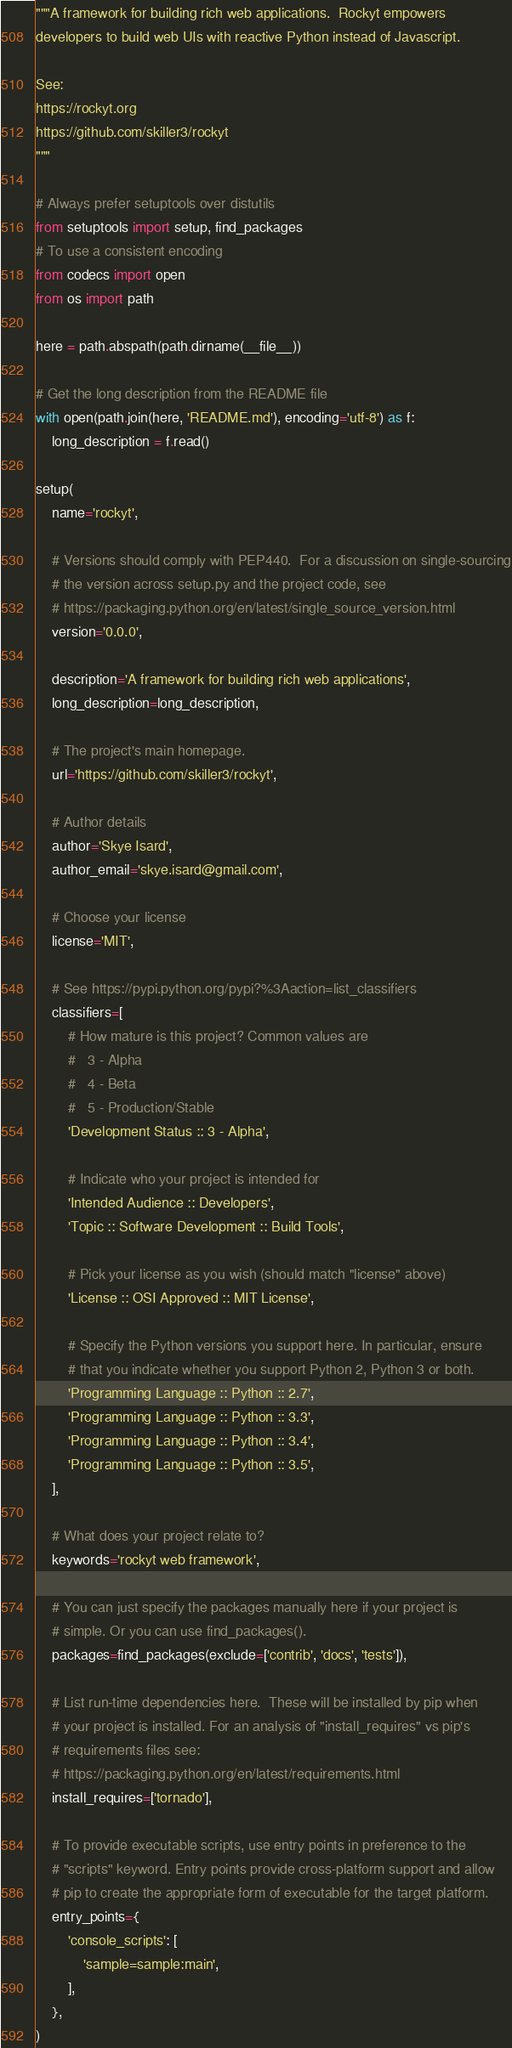<code> <loc_0><loc_0><loc_500><loc_500><_Python_>"""A framework for building rich web applications.  Rockyt empowers
developers to build web UIs with reactive Python instead of Javascript.

See:
https://rockyt.org
https://github.com/skiller3/rockyt
"""

# Always prefer setuptools over distutils
from setuptools import setup, find_packages
# To use a consistent encoding
from codecs import open
from os import path

here = path.abspath(path.dirname(__file__))

# Get the long description from the README file
with open(path.join(here, 'README.md'), encoding='utf-8') as f:
    long_description = f.read()

setup(
    name='rockyt',

    # Versions should comply with PEP440.  For a discussion on single-sourcing
    # the version across setup.py and the project code, see
    # https://packaging.python.org/en/latest/single_source_version.html
    version='0.0.0',

    description='A framework for building rich web applications',
    long_description=long_description,

    # The project's main homepage.
    url='https://github.com/skiller3/rockyt',

    # Author details
    author='Skye Isard',
    author_email='skye.isard@gmail.com',

    # Choose your license
    license='MIT',

    # See https://pypi.python.org/pypi?%3Aaction=list_classifiers
    classifiers=[
        # How mature is this project? Common values are
        #   3 - Alpha
        #   4 - Beta
        #   5 - Production/Stable
        'Development Status :: 3 - Alpha',

        # Indicate who your project is intended for
        'Intended Audience :: Developers',
        'Topic :: Software Development :: Build Tools',

        # Pick your license as you wish (should match "license" above)
        'License :: OSI Approved :: MIT License',

        # Specify the Python versions you support here. In particular, ensure
        # that you indicate whether you support Python 2, Python 3 or both.
        'Programming Language :: Python :: 2.7',
        'Programming Language :: Python :: 3.3',
        'Programming Language :: Python :: 3.4',
        'Programming Language :: Python :: 3.5',
    ],

    # What does your project relate to?
    keywords='rockyt web framework',

    # You can just specify the packages manually here if your project is
    # simple. Or you can use find_packages().
    packages=find_packages(exclude=['contrib', 'docs', 'tests']),
    
    # List run-time dependencies here.  These will be installed by pip when
    # your project is installed. For an analysis of "install_requires" vs pip's
    # requirements files see:
    # https://packaging.python.org/en/latest/requirements.html
    install_requires=['tornado'],

    # To provide executable scripts, use entry points in preference to the
    # "scripts" keyword. Entry points provide cross-platform support and allow
    # pip to create the appropriate form of executable for the target platform.
    entry_points={
        'console_scripts': [
            'sample=sample:main',
        ],
    },
)
</code> 